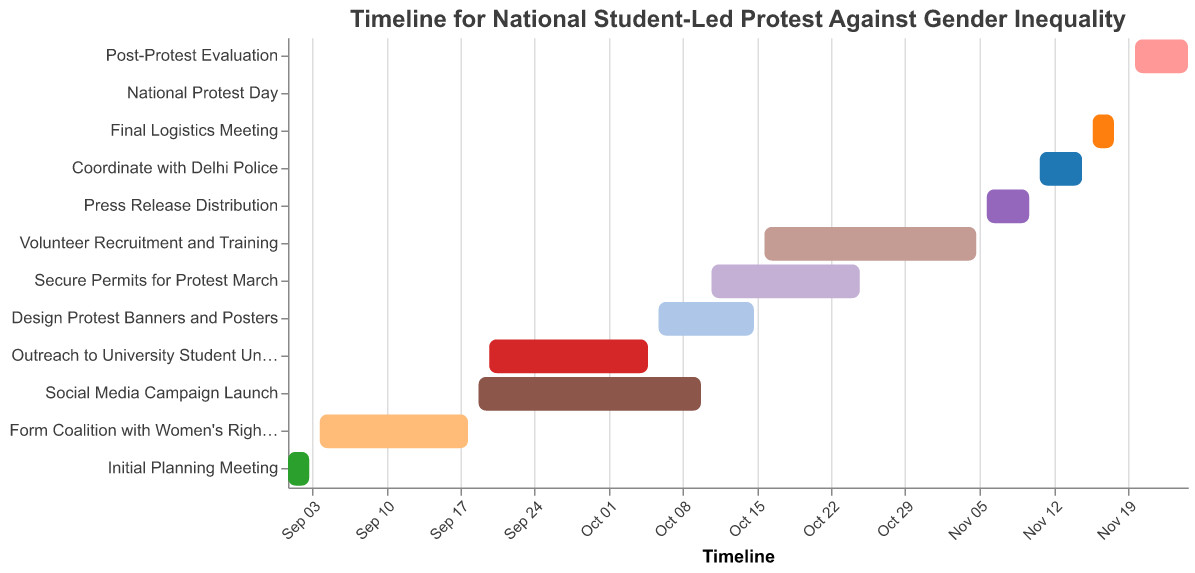What is the title of the Gantt chart? The title is displayed at the top of the chart. It provides the main theme or purpose of the chart.
Answer: Timeline for National Student-Led Protest Against Gender Inequality When does the 'Design Protest Banners and Posters' task start and end? The task start and end dates are indicated by the bars for each task. Look for the 'Design Protest Banners and Posters' bar.
Answer: 2023-10-06 to 2023-10-15 Which tasks overlap with 'Outreach to University Student Unions'? Identify the bar for 'Outreach to University Student Unions' and see which other task bars overlap in the same time period.
Answer: Social Media Campaign Launch How many days is 'Volunteer Recruitment and Training' planned to take? Find the start and end dates for 'Volunteer Recruitment and Training' and calculate the difference in days.
Answer: 20 days Which task ends first in October? Check which tasks are scheduled to end in October and compare their end dates.
Answer: Outreach to University Student Unions What is the duration of the 'Social Media Campaign Launch'? Look at the start and end dates of 'Social Media Campaign Launch' and calculate the difference in days.
Answer: 22 days During which task is 'Secure Permits for Protest March' planned to be executed? Identify the period of 'Secure Permits for Protest March' and see which bars overlap this time frame.
Answer: Volunteer Recruitment and Training What is the longest task in the chart? Compare the duration of all tasks by calculating the number of days from start to end for each task.
Answer: Volunteer Recruitment and Training What tasks are planned from October 11 to November 5? Identify which tasks' bars cover the period from October 11 to November 5.
Answer: Secure Permits for Protest March, Volunteer Recruitment and Training When is the 'National Protest Day' scheduled? Look for the bar labeled 'National Protest Day' to find its scheduled date.
Answer: 2023-11-19 